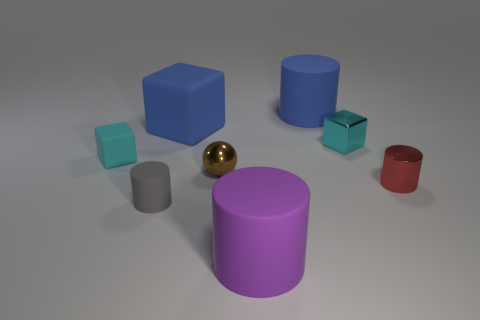There is a large thing that is the same color as the big matte cube; what is it made of?
Your answer should be compact. Rubber. Are there any other things that have the same material as the brown thing?
Ensure brevity in your answer.  Yes. Do the small ball and the shiny cylinder have the same color?
Ensure brevity in your answer.  No. There is a brown object that is the same material as the tiny red cylinder; what shape is it?
Your answer should be compact. Sphere. What number of other purple rubber things are the same shape as the purple rubber thing?
Provide a short and direct response. 0. There is a tiny matte object in front of the cyan block that is to the left of the tiny gray matte cylinder; what is its shape?
Give a very brief answer. Cylinder. Does the brown sphere that is to the left of the purple rubber object have the same size as the red thing?
Provide a succinct answer. Yes. What size is the rubber object that is both right of the tiny brown object and behind the small cyan shiny cube?
Make the answer very short. Large. What number of shiny spheres are the same size as the red cylinder?
Provide a succinct answer. 1. What number of small cyan objects are on the left side of the cylinder that is on the left side of the big purple object?
Provide a succinct answer. 1. 